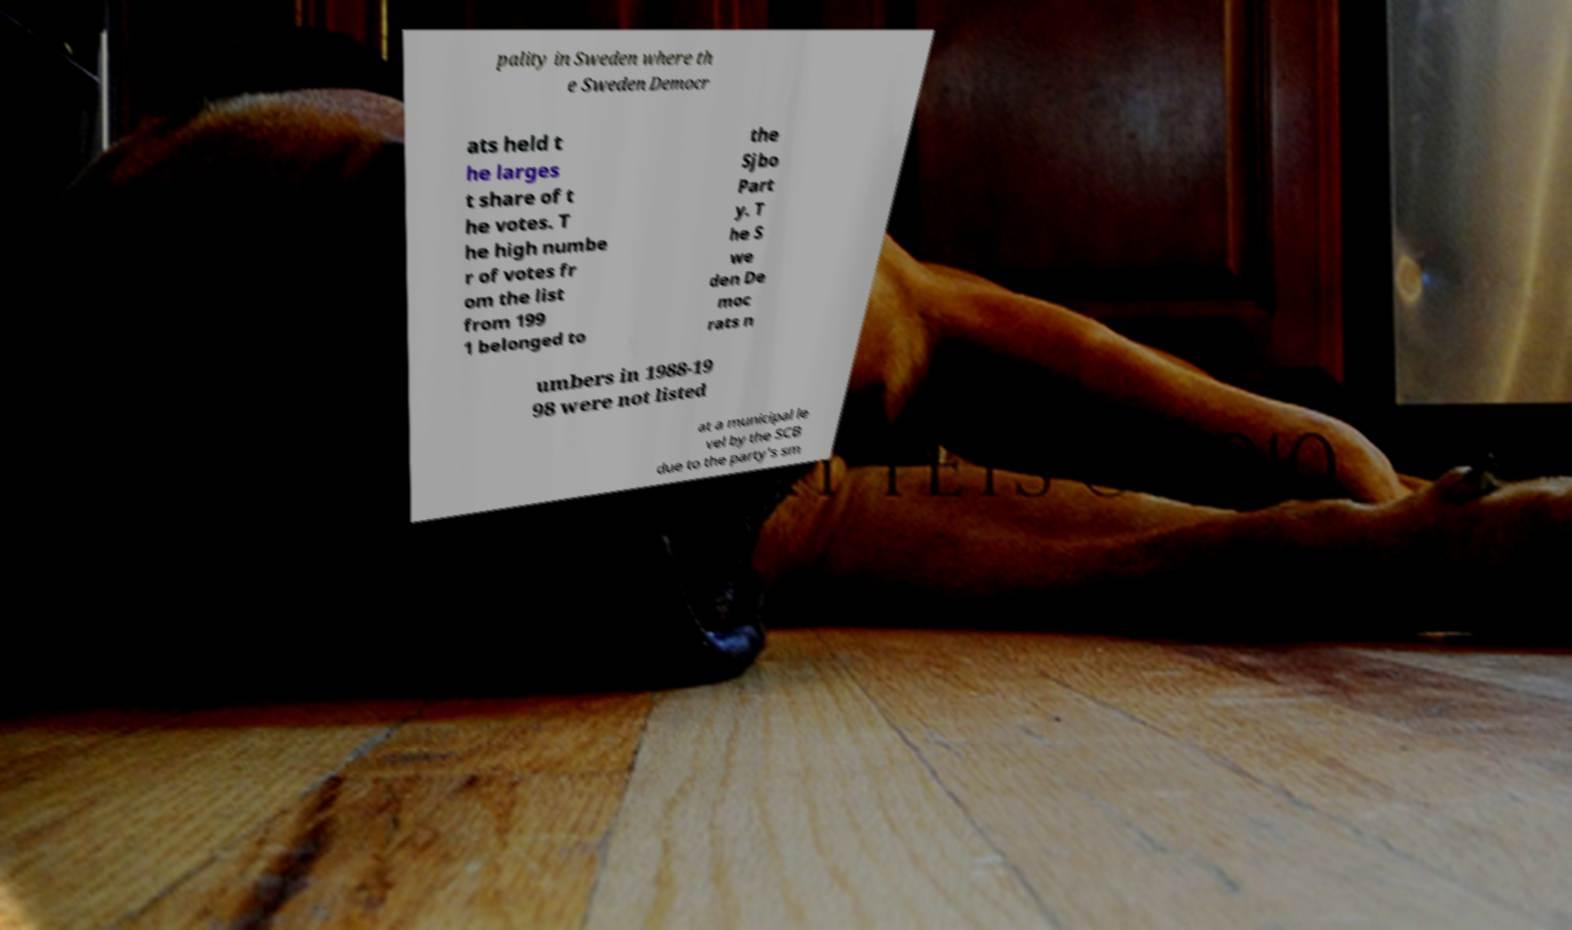Could you assist in decoding the text presented in this image and type it out clearly? pality in Sweden where th e Sweden Democr ats held t he larges t share of t he votes. T he high numbe r of votes fr om the list from 199 1 belonged to the Sjbo Part y. T he S we den De moc rats n umbers in 1988-19 98 were not listed at a municipal le vel by the SCB due to the party's sm 